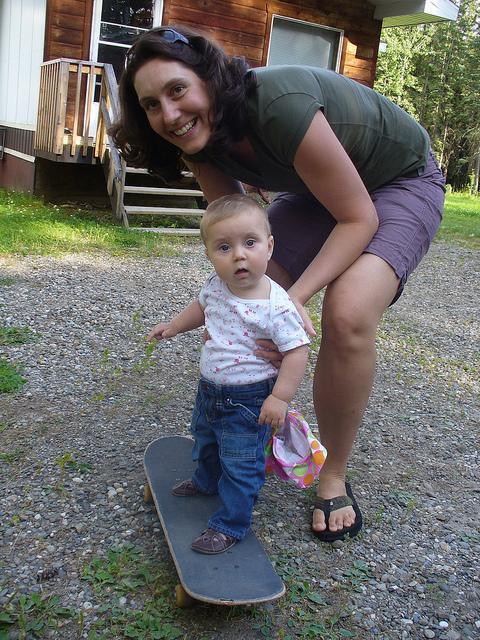What brand of sandals is the woman wearing?
Choose the right answer from the provided options to respond to the question.
Options: Adidas, nike, reef, pacsun. Reef. 